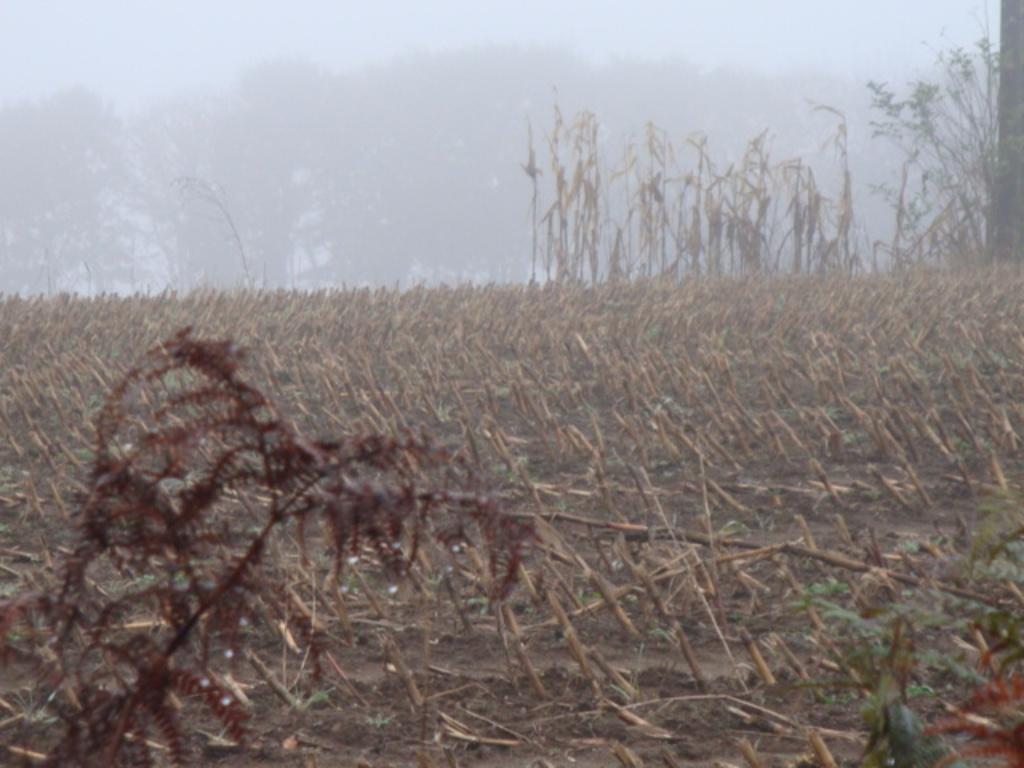In one or two sentences, can you explain what this image depicts? This image is taken outdoors. In the background there are many trees. At the top of the image there is the sky. In the middle of the image there is a ground with a few dry plants and there are a few plants. 